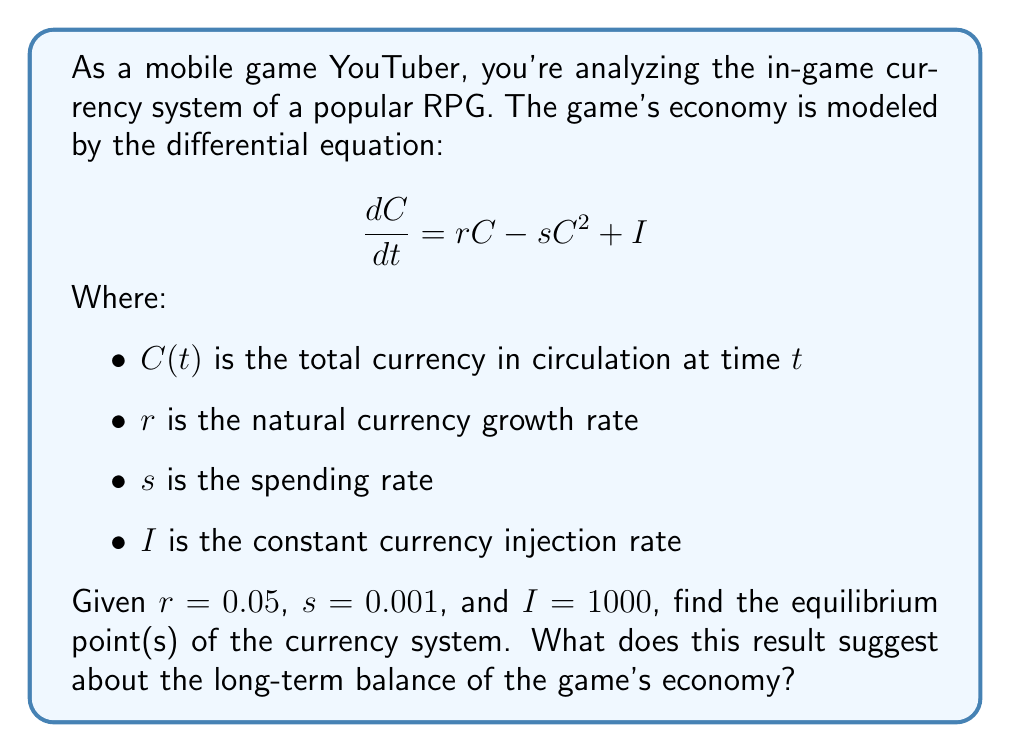Provide a solution to this math problem. Let's approach this step-by-step:

1) The equilibrium points occur when $\frac{dC}{dt} = 0$. So, we need to solve:

   $$0 = rC - sC^2 + I$$

2) Substituting the given values:

   $$0 = 0.05C - 0.001C^2 + 1000$$

3) Rearranging the equation:

   $$0.001C^2 - 0.05C - 1000 = 0$$

4) This is a quadratic equation. We can solve it using the quadratic formula:

   $$C = \frac{-b \pm \sqrt{b^2 - 4ac}}{2a}$$

   Where $a = 0.001$, $b = -0.05$, and $c = -1000$

5) Substituting these values:

   $$C = \frac{0.05 \pm \sqrt{(-0.05)^2 - 4(0.001)(-1000)}}{2(0.001)}$$

6) Simplifying:

   $$C = \frac{0.05 \pm \sqrt{0.0025 + 4}}{0.002} = \frac{0.05 \pm \sqrt{4.0025}}{0.002}$$

7) Calculating:

   $$C \approx \frac{0.05 \pm 2.001}{0.002}$$

8) This gives us two equilibrium points:

   $$C_1 \approx 1025.5 \text{ and } C_2 \approx -975.5$$

9) Since currency can't be negative, we discard the negative solution.

This result suggests that the game's economy will naturally tend towards a balance of approximately 1025.5 units of currency in circulation over time, regardless of the starting amount. This equilibrium point represents a stable state where currency inflow (from growth and injection) equals outflow (from spending).
Answer: Equilibrium point: $C \approx 1025.5$ currency units 